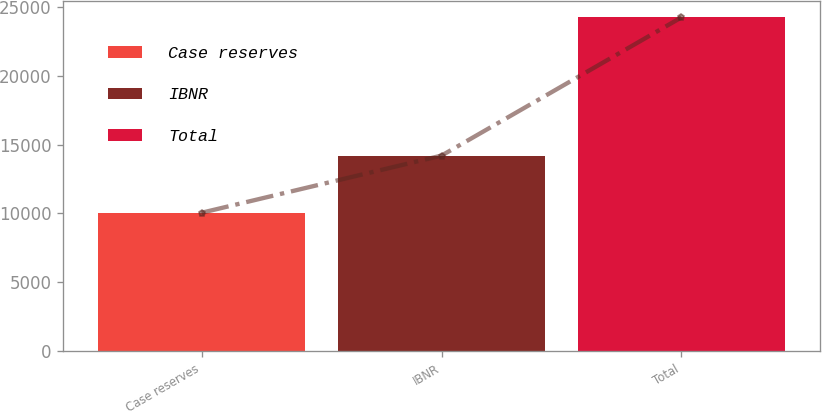Convert chart. <chart><loc_0><loc_0><loc_500><loc_500><bar_chart><fcel>Case reserves<fcel>IBNR<fcel>Total<nl><fcel>10044<fcel>14197<fcel>24241<nl></chart> 